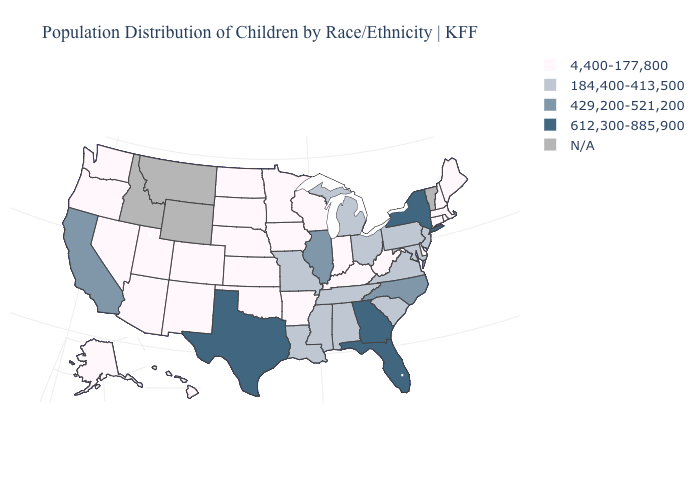What is the value of Oklahoma?
Short answer required. 4,400-177,800. Which states have the lowest value in the USA?
Be succinct. Alaska, Arizona, Arkansas, Colorado, Connecticut, Delaware, Hawaii, Indiana, Iowa, Kansas, Kentucky, Maine, Massachusetts, Minnesota, Nebraska, Nevada, New Hampshire, New Mexico, North Dakota, Oklahoma, Oregon, Rhode Island, South Dakota, Utah, Washington, West Virginia, Wisconsin. Is the legend a continuous bar?
Give a very brief answer. No. What is the highest value in the South ?
Concise answer only. 612,300-885,900. What is the value of Maryland?
Short answer required. 184,400-413,500. Name the states that have a value in the range N/A?
Answer briefly. Idaho, Montana, Vermont, Wyoming. What is the highest value in the South ?
Answer briefly. 612,300-885,900. What is the lowest value in states that border Massachusetts?
Give a very brief answer. 4,400-177,800. Does Alaska have the lowest value in the USA?
Answer briefly. Yes. Among the states that border North Dakota , which have the lowest value?
Keep it brief. Minnesota, South Dakota. Which states have the lowest value in the USA?
Give a very brief answer. Alaska, Arizona, Arkansas, Colorado, Connecticut, Delaware, Hawaii, Indiana, Iowa, Kansas, Kentucky, Maine, Massachusetts, Minnesota, Nebraska, Nevada, New Hampshire, New Mexico, North Dakota, Oklahoma, Oregon, Rhode Island, South Dakota, Utah, Washington, West Virginia, Wisconsin. Name the states that have a value in the range 184,400-413,500?
Be succinct. Alabama, Louisiana, Maryland, Michigan, Mississippi, Missouri, New Jersey, Ohio, Pennsylvania, South Carolina, Tennessee, Virginia. Does Florida have the highest value in the USA?
Write a very short answer. Yes. Which states have the lowest value in the USA?
Write a very short answer. Alaska, Arizona, Arkansas, Colorado, Connecticut, Delaware, Hawaii, Indiana, Iowa, Kansas, Kentucky, Maine, Massachusetts, Minnesota, Nebraska, Nevada, New Hampshire, New Mexico, North Dakota, Oklahoma, Oregon, Rhode Island, South Dakota, Utah, Washington, West Virginia, Wisconsin. 